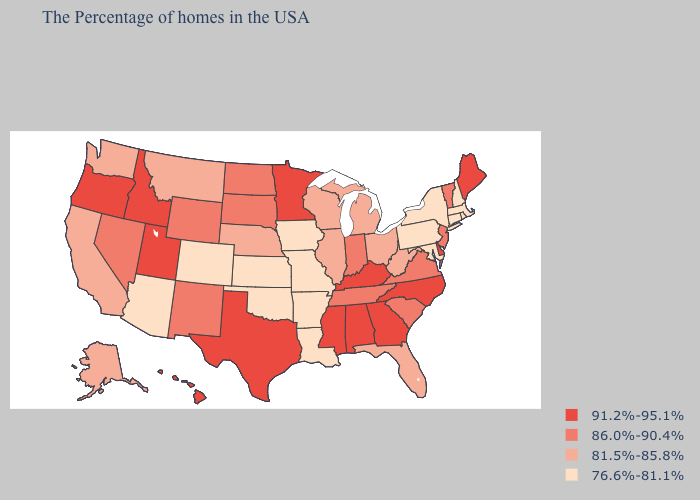Name the states that have a value in the range 76.6%-81.1%?
Concise answer only. Massachusetts, Rhode Island, New Hampshire, Connecticut, New York, Maryland, Pennsylvania, Louisiana, Missouri, Arkansas, Iowa, Kansas, Oklahoma, Colorado, Arizona. Name the states that have a value in the range 81.5%-85.8%?
Concise answer only. West Virginia, Ohio, Florida, Michigan, Wisconsin, Illinois, Nebraska, Montana, California, Washington, Alaska. Does the first symbol in the legend represent the smallest category?
Quick response, please. No. Does the map have missing data?
Answer briefly. No. Does Iowa have the lowest value in the USA?
Write a very short answer. Yes. Name the states that have a value in the range 86.0%-90.4%?
Be succinct. Vermont, New Jersey, Virginia, South Carolina, Indiana, Tennessee, South Dakota, North Dakota, Wyoming, New Mexico, Nevada. Name the states that have a value in the range 91.2%-95.1%?
Keep it brief. Maine, Delaware, North Carolina, Georgia, Kentucky, Alabama, Mississippi, Minnesota, Texas, Utah, Idaho, Oregon, Hawaii. Name the states that have a value in the range 76.6%-81.1%?
Give a very brief answer. Massachusetts, Rhode Island, New Hampshire, Connecticut, New York, Maryland, Pennsylvania, Louisiana, Missouri, Arkansas, Iowa, Kansas, Oklahoma, Colorado, Arizona. What is the highest value in states that border California?
Be succinct. 91.2%-95.1%. How many symbols are there in the legend?
Quick response, please. 4. Does the map have missing data?
Short answer required. No. Does Illinois have a lower value than Maryland?
Short answer required. No. What is the highest value in the South ?
Answer briefly. 91.2%-95.1%. What is the highest value in the West ?
Be succinct. 91.2%-95.1%. Which states have the lowest value in the MidWest?
Give a very brief answer. Missouri, Iowa, Kansas. 